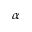<formula> <loc_0><loc_0><loc_500><loc_500>\alpha</formula> 